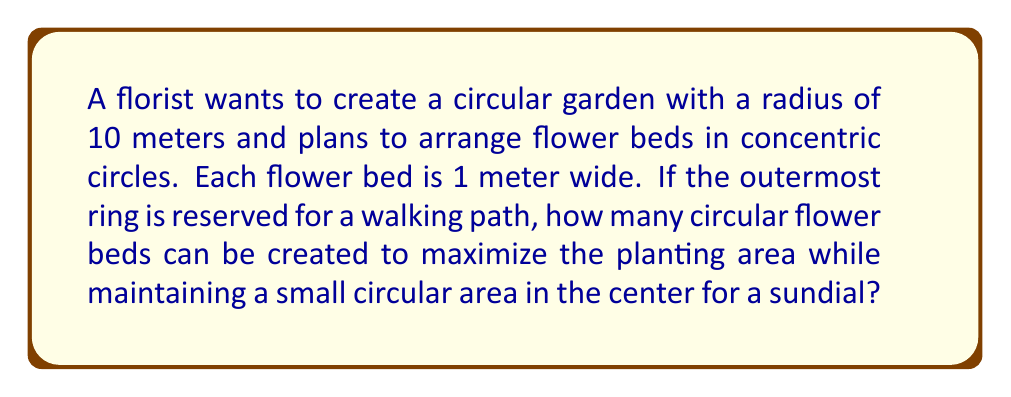Give your solution to this math problem. Let's approach this step-by-step:

1) The garden has a radius of 10 meters, but the outermost ring (1 meter wide) is reserved for a path. So, the available radius for flower beds is 9 meters.

2) Each flower bed is 1 meter wide. Let's denote the number of flower beds as $n$.

3) The area of a circle is given by the formula $A = \pi r^2$.

4) The total area available for planting is the area of a circle with radius 9 meters:
   $A_{total} = \pi (9)^2 = 81\pi$ square meters

5) The area of each circular flower bed can be calculated as the difference between two circles:
   $A_{bed} = \pi (r_{outer}^2 - r_{inner}^2)$

6) For $n$ flower beds, we have:
   $r_{outer} = 9 - i + 1$ and $r_{inner} = 9 - i$ for $i = 1, 2, ..., n$

7) The total area of all flower beds is:
   $$A_{beds} = \sum_{i=1}^n \pi ((9-i+1)^2 - (9-i)^2)$$
              $= \pi \sum_{i=1}^n (19 - 2i)$
              $= \pi (19n - n(n+1))$
              $= \pi (19n - n^2 - n)$
              $= \pi (18n - n^2)$

8) To maximize the planting area, we want to find the maximum value of this function. We can do this by differentiating with respect to $n$ and setting it to zero:

   $\frac{d}{dn}(18n - n^2) = 18 - 2n = 0$
   $18 = 2n$
   $n = 9$

9) The second derivative is negative, confirming this is a maximum.

10) However, since $n$ must be an integer, we should check both 8 and 9 flower beds:

    For 8 beds: $\pi(18(8) - 8^2) = 80\pi$
    For 9 beds: $\pi(18(9) - 9^2) = 81\pi$

11) 9 beds gives the maximum area, which is equal to the total available area.

12) This leaves no space for the sundial in the center. Therefore, we should use 8 flower beds, which leaves a small circular area in the center with a radius of 1 meter for the sundial.
Answer: The most efficient arrangement is 8 circular flower beds, each 1 meter wide, leaving a 1-meter radius circle in the center for a sundial. 